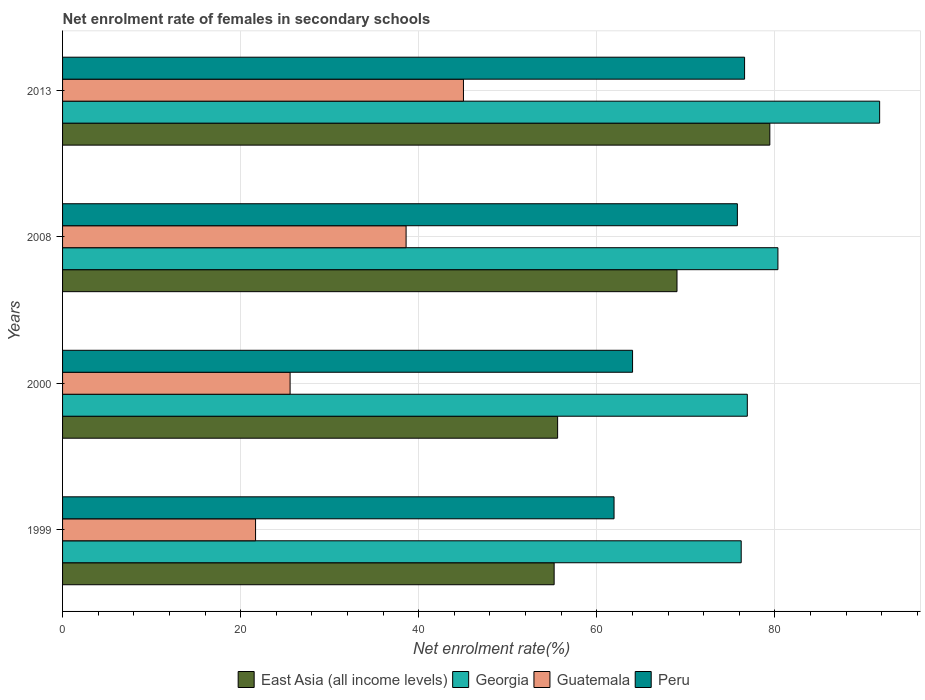How many different coloured bars are there?
Provide a short and direct response. 4. How many groups of bars are there?
Give a very brief answer. 4. Are the number of bars per tick equal to the number of legend labels?
Your answer should be compact. Yes. How many bars are there on the 1st tick from the bottom?
Your answer should be compact. 4. In how many cases, is the number of bars for a given year not equal to the number of legend labels?
Provide a short and direct response. 0. What is the net enrolment rate of females in secondary schools in East Asia (all income levels) in 1999?
Offer a very short reply. 55.21. Across all years, what is the maximum net enrolment rate of females in secondary schools in East Asia (all income levels)?
Ensure brevity in your answer.  79.43. Across all years, what is the minimum net enrolment rate of females in secondary schools in Peru?
Your answer should be compact. 61.94. In which year was the net enrolment rate of females in secondary schools in Georgia minimum?
Offer a very short reply. 1999. What is the total net enrolment rate of females in secondary schools in Guatemala in the graph?
Your answer should be very brief. 130.83. What is the difference between the net enrolment rate of females in secondary schools in Georgia in 1999 and that in 2008?
Provide a short and direct response. -4.12. What is the difference between the net enrolment rate of females in secondary schools in Guatemala in 2000 and the net enrolment rate of females in secondary schools in East Asia (all income levels) in 1999?
Ensure brevity in your answer.  -29.66. What is the average net enrolment rate of females in secondary schools in East Asia (all income levels) per year?
Make the answer very short. 64.81. In the year 2008, what is the difference between the net enrolment rate of females in secondary schools in Georgia and net enrolment rate of females in secondary schools in Peru?
Offer a terse response. 4.55. In how many years, is the net enrolment rate of females in secondary schools in Georgia greater than 52 %?
Keep it short and to the point. 4. What is the ratio of the net enrolment rate of females in secondary schools in Georgia in 1999 to that in 2008?
Give a very brief answer. 0.95. What is the difference between the highest and the second highest net enrolment rate of females in secondary schools in East Asia (all income levels)?
Your response must be concise. 10.43. What is the difference between the highest and the lowest net enrolment rate of females in secondary schools in Georgia?
Make the answer very short. 15.55. What does the 3rd bar from the top in 2000 represents?
Give a very brief answer. Georgia. What does the 1st bar from the bottom in 2013 represents?
Offer a very short reply. East Asia (all income levels). How many bars are there?
Ensure brevity in your answer.  16. How many years are there in the graph?
Provide a succinct answer. 4. What is the difference between two consecutive major ticks on the X-axis?
Keep it short and to the point. 20. Does the graph contain grids?
Offer a terse response. Yes. Where does the legend appear in the graph?
Your response must be concise. Bottom center. How are the legend labels stacked?
Give a very brief answer. Horizontal. What is the title of the graph?
Your response must be concise. Net enrolment rate of females in secondary schools. Does "Upper middle income" appear as one of the legend labels in the graph?
Ensure brevity in your answer.  No. What is the label or title of the X-axis?
Your response must be concise. Net enrolment rate(%). What is the label or title of the Y-axis?
Offer a very short reply. Years. What is the Net enrolment rate(%) of East Asia (all income levels) in 1999?
Offer a very short reply. 55.21. What is the Net enrolment rate(%) of Georgia in 1999?
Keep it short and to the point. 76.22. What is the Net enrolment rate(%) of Guatemala in 1999?
Give a very brief answer. 21.68. What is the Net enrolment rate(%) of Peru in 1999?
Your answer should be compact. 61.94. What is the Net enrolment rate(%) in East Asia (all income levels) in 2000?
Offer a terse response. 55.6. What is the Net enrolment rate(%) in Georgia in 2000?
Offer a very short reply. 76.9. What is the Net enrolment rate(%) of Guatemala in 2000?
Offer a very short reply. 25.55. What is the Net enrolment rate(%) of Peru in 2000?
Ensure brevity in your answer.  64.02. What is the Net enrolment rate(%) of East Asia (all income levels) in 2008?
Offer a very short reply. 69.01. What is the Net enrolment rate(%) in Georgia in 2008?
Ensure brevity in your answer.  80.34. What is the Net enrolment rate(%) in Guatemala in 2008?
Make the answer very short. 38.58. What is the Net enrolment rate(%) in Peru in 2008?
Provide a succinct answer. 75.79. What is the Net enrolment rate(%) in East Asia (all income levels) in 2013?
Offer a very short reply. 79.43. What is the Net enrolment rate(%) of Georgia in 2013?
Your answer should be compact. 91.77. What is the Net enrolment rate(%) in Guatemala in 2013?
Give a very brief answer. 45.02. What is the Net enrolment rate(%) of Peru in 2013?
Keep it short and to the point. 76.6. Across all years, what is the maximum Net enrolment rate(%) of East Asia (all income levels)?
Provide a short and direct response. 79.43. Across all years, what is the maximum Net enrolment rate(%) in Georgia?
Keep it short and to the point. 91.77. Across all years, what is the maximum Net enrolment rate(%) of Guatemala?
Your answer should be very brief. 45.02. Across all years, what is the maximum Net enrolment rate(%) in Peru?
Offer a very short reply. 76.6. Across all years, what is the minimum Net enrolment rate(%) of East Asia (all income levels)?
Your response must be concise. 55.21. Across all years, what is the minimum Net enrolment rate(%) in Georgia?
Offer a very short reply. 76.22. Across all years, what is the minimum Net enrolment rate(%) in Guatemala?
Provide a succinct answer. 21.68. Across all years, what is the minimum Net enrolment rate(%) of Peru?
Offer a very short reply. 61.94. What is the total Net enrolment rate(%) of East Asia (all income levels) in the graph?
Provide a short and direct response. 259.25. What is the total Net enrolment rate(%) of Georgia in the graph?
Your answer should be very brief. 325.23. What is the total Net enrolment rate(%) of Guatemala in the graph?
Ensure brevity in your answer.  130.83. What is the total Net enrolment rate(%) of Peru in the graph?
Provide a succinct answer. 278.34. What is the difference between the Net enrolment rate(%) of East Asia (all income levels) in 1999 and that in 2000?
Offer a terse response. -0.39. What is the difference between the Net enrolment rate(%) of Georgia in 1999 and that in 2000?
Offer a terse response. -0.69. What is the difference between the Net enrolment rate(%) in Guatemala in 1999 and that in 2000?
Provide a short and direct response. -3.88. What is the difference between the Net enrolment rate(%) in Peru in 1999 and that in 2000?
Your answer should be compact. -2.08. What is the difference between the Net enrolment rate(%) of East Asia (all income levels) in 1999 and that in 2008?
Your answer should be compact. -13.8. What is the difference between the Net enrolment rate(%) of Georgia in 1999 and that in 2008?
Make the answer very short. -4.12. What is the difference between the Net enrolment rate(%) of Guatemala in 1999 and that in 2008?
Offer a terse response. -16.91. What is the difference between the Net enrolment rate(%) in Peru in 1999 and that in 2008?
Make the answer very short. -13.85. What is the difference between the Net enrolment rate(%) in East Asia (all income levels) in 1999 and that in 2013?
Your response must be concise. -24.22. What is the difference between the Net enrolment rate(%) in Georgia in 1999 and that in 2013?
Ensure brevity in your answer.  -15.55. What is the difference between the Net enrolment rate(%) in Guatemala in 1999 and that in 2013?
Keep it short and to the point. -23.35. What is the difference between the Net enrolment rate(%) in Peru in 1999 and that in 2013?
Make the answer very short. -14.66. What is the difference between the Net enrolment rate(%) of East Asia (all income levels) in 2000 and that in 2008?
Your answer should be compact. -13.41. What is the difference between the Net enrolment rate(%) of Georgia in 2000 and that in 2008?
Make the answer very short. -3.44. What is the difference between the Net enrolment rate(%) of Guatemala in 2000 and that in 2008?
Give a very brief answer. -13.03. What is the difference between the Net enrolment rate(%) of Peru in 2000 and that in 2008?
Provide a succinct answer. -11.77. What is the difference between the Net enrolment rate(%) of East Asia (all income levels) in 2000 and that in 2013?
Provide a succinct answer. -23.83. What is the difference between the Net enrolment rate(%) in Georgia in 2000 and that in 2013?
Provide a short and direct response. -14.86. What is the difference between the Net enrolment rate(%) of Guatemala in 2000 and that in 2013?
Offer a very short reply. -19.47. What is the difference between the Net enrolment rate(%) in Peru in 2000 and that in 2013?
Ensure brevity in your answer.  -12.58. What is the difference between the Net enrolment rate(%) of East Asia (all income levels) in 2008 and that in 2013?
Offer a very short reply. -10.43. What is the difference between the Net enrolment rate(%) of Georgia in 2008 and that in 2013?
Give a very brief answer. -11.42. What is the difference between the Net enrolment rate(%) in Guatemala in 2008 and that in 2013?
Provide a short and direct response. -6.44. What is the difference between the Net enrolment rate(%) of Peru in 2008 and that in 2013?
Offer a very short reply. -0.81. What is the difference between the Net enrolment rate(%) of East Asia (all income levels) in 1999 and the Net enrolment rate(%) of Georgia in 2000?
Provide a succinct answer. -21.69. What is the difference between the Net enrolment rate(%) of East Asia (all income levels) in 1999 and the Net enrolment rate(%) of Guatemala in 2000?
Offer a terse response. 29.66. What is the difference between the Net enrolment rate(%) of East Asia (all income levels) in 1999 and the Net enrolment rate(%) of Peru in 2000?
Your answer should be very brief. -8.81. What is the difference between the Net enrolment rate(%) in Georgia in 1999 and the Net enrolment rate(%) in Guatemala in 2000?
Give a very brief answer. 50.66. What is the difference between the Net enrolment rate(%) of Georgia in 1999 and the Net enrolment rate(%) of Peru in 2000?
Make the answer very short. 12.2. What is the difference between the Net enrolment rate(%) of Guatemala in 1999 and the Net enrolment rate(%) of Peru in 2000?
Ensure brevity in your answer.  -42.34. What is the difference between the Net enrolment rate(%) of East Asia (all income levels) in 1999 and the Net enrolment rate(%) of Georgia in 2008?
Provide a succinct answer. -25.13. What is the difference between the Net enrolment rate(%) of East Asia (all income levels) in 1999 and the Net enrolment rate(%) of Guatemala in 2008?
Your answer should be very brief. 16.63. What is the difference between the Net enrolment rate(%) of East Asia (all income levels) in 1999 and the Net enrolment rate(%) of Peru in 2008?
Offer a terse response. -20.58. What is the difference between the Net enrolment rate(%) of Georgia in 1999 and the Net enrolment rate(%) of Guatemala in 2008?
Offer a very short reply. 37.64. What is the difference between the Net enrolment rate(%) of Georgia in 1999 and the Net enrolment rate(%) of Peru in 2008?
Give a very brief answer. 0.43. What is the difference between the Net enrolment rate(%) in Guatemala in 1999 and the Net enrolment rate(%) in Peru in 2008?
Ensure brevity in your answer.  -54.11. What is the difference between the Net enrolment rate(%) of East Asia (all income levels) in 1999 and the Net enrolment rate(%) of Georgia in 2013?
Your answer should be very brief. -36.56. What is the difference between the Net enrolment rate(%) in East Asia (all income levels) in 1999 and the Net enrolment rate(%) in Guatemala in 2013?
Your answer should be compact. 10.19. What is the difference between the Net enrolment rate(%) in East Asia (all income levels) in 1999 and the Net enrolment rate(%) in Peru in 2013?
Provide a succinct answer. -21.39. What is the difference between the Net enrolment rate(%) in Georgia in 1999 and the Net enrolment rate(%) in Guatemala in 2013?
Make the answer very short. 31.2. What is the difference between the Net enrolment rate(%) of Georgia in 1999 and the Net enrolment rate(%) of Peru in 2013?
Provide a succinct answer. -0.38. What is the difference between the Net enrolment rate(%) in Guatemala in 1999 and the Net enrolment rate(%) in Peru in 2013?
Make the answer very short. -54.92. What is the difference between the Net enrolment rate(%) in East Asia (all income levels) in 2000 and the Net enrolment rate(%) in Georgia in 2008?
Ensure brevity in your answer.  -24.74. What is the difference between the Net enrolment rate(%) of East Asia (all income levels) in 2000 and the Net enrolment rate(%) of Guatemala in 2008?
Make the answer very short. 17.02. What is the difference between the Net enrolment rate(%) of East Asia (all income levels) in 2000 and the Net enrolment rate(%) of Peru in 2008?
Provide a succinct answer. -20.19. What is the difference between the Net enrolment rate(%) of Georgia in 2000 and the Net enrolment rate(%) of Guatemala in 2008?
Ensure brevity in your answer.  38.32. What is the difference between the Net enrolment rate(%) of Georgia in 2000 and the Net enrolment rate(%) of Peru in 2008?
Your answer should be compact. 1.12. What is the difference between the Net enrolment rate(%) in Guatemala in 2000 and the Net enrolment rate(%) in Peru in 2008?
Provide a succinct answer. -50.23. What is the difference between the Net enrolment rate(%) in East Asia (all income levels) in 2000 and the Net enrolment rate(%) in Georgia in 2013?
Keep it short and to the point. -36.17. What is the difference between the Net enrolment rate(%) of East Asia (all income levels) in 2000 and the Net enrolment rate(%) of Guatemala in 2013?
Make the answer very short. 10.58. What is the difference between the Net enrolment rate(%) in East Asia (all income levels) in 2000 and the Net enrolment rate(%) in Peru in 2013?
Offer a terse response. -21. What is the difference between the Net enrolment rate(%) in Georgia in 2000 and the Net enrolment rate(%) in Guatemala in 2013?
Your answer should be very brief. 31.88. What is the difference between the Net enrolment rate(%) of Georgia in 2000 and the Net enrolment rate(%) of Peru in 2013?
Provide a succinct answer. 0.31. What is the difference between the Net enrolment rate(%) of Guatemala in 2000 and the Net enrolment rate(%) of Peru in 2013?
Your response must be concise. -51.04. What is the difference between the Net enrolment rate(%) of East Asia (all income levels) in 2008 and the Net enrolment rate(%) of Georgia in 2013?
Provide a succinct answer. -22.76. What is the difference between the Net enrolment rate(%) in East Asia (all income levels) in 2008 and the Net enrolment rate(%) in Guatemala in 2013?
Provide a succinct answer. 23.98. What is the difference between the Net enrolment rate(%) in East Asia (all income levels) in 2008 and the Net enrolment rate(%) in Peru in 2013?
Offer a terse response. -7.59. What is the difference between the Net enrolment rate(%) of Georgia in 2008 and the Net enrolment rate(%) of Guatemala in 2013?
Provide a succinct answer. 35.32. What is the difference between the Net enrolment rate(%) of Georgia in 2008 and the Net enrolment rate(%) of Peru in 2013?
Offer a terse response. 3.75. What is the difference between the Net enrolment rate(%) of Guatemala in 2008 and the Net enrolment rate(%) of Peru in 2013?
Offer a terse response. -38.02. What is the average Net enrolment rate(%) of East Asia (all income levels) per year?
Offer a very short reply. 64.81. What is the average Net enrolment rate(%) of Georgia per year?
Give a very brief answer. 81.31. What is the average Net enrolment rate(%) of Guatemala per year?
Offer a very short reply. 32.71. What is the average Net enrolment rate(%) in Peru per year?
Provide a short and direct response. 69.58. In the year 1999, what is the difference between the Net enrolment rate(%) of East Asia (all income levels) and Net enrolment rate(%) of Georgia?
Keep it short and to the point. -21.01. In the year 1999, what is the difference between the Net enrolment rate(%) in East Asia (all income levels) and Net enrolment rate(%) in Guatemala?
Your answer should be very brief. 33.53. In the year 1999, what is the difference between the Net enrolment rate(%) of East Asia (all income levels) and Net enrolment rate(%) of Peru?
Your answer should be compact. -6.73. In the year 1999, what is the difference between the Net enrolment rate(%) of Georgia and Net enrolment rate(%) of Guatemala?
Keep it short and to the point. 54.54. In the year 1999, what is the difference between the Net enrolment rate(%) in Georgia and Net enrolment rate(%) in Peru?
Offer a terse response. 14.28. In the year 1999, what is the difference between the Net enrolment rate(%) in Guatemala and Net enrolment rate(%) in Peru?
Your answer should be compact. -40.26. In the year 2000, what is the difference between the Net enrolment rate(%) of East Asia (all income levels) and Net enrolment rate(%) of Georgia?
Keep it short and to the point. -21.3. In the year 2000, what is the difference between the Net enrolment rate(%) in East Asia (all income levels) and Net enrolment rate(%) in Guatemala?
Give a very brief answer. 30.05. In the year 2000, what is the difference between the Net enrolment rate(%) in East Asia (all income levels) and Net enrolment rate(%) in Peru?
Your answer should be compact. -8.42. In the year 2000, what is the difference between the Net enrolment rate(%) in Georgia and Net enrolment rate(%) in Guatemala?
Your answer should be very brief. 51.35. In the year 2000, what is the difference between the Net enrolment rate(%) in Georgia and Net enrolment rate(%) in Peru?
Provide a short and direct response. 12.89. In the year 2000, what is the difference between the Net enrolment rate(%) of Guatemala and Net enrolment rate(%) of Peru?
Offer a very short reply. -38.46. In the year 2008, what is the difference between the Net enrolment rate(%) in East Asia (all income levels) and Net enrolment rate(%) in Georgia?
Offer a terse response. -11.33. In the year 2008, what is the difference between the Net enrolment rate(%) in East Asia (all income levels) and Net enrolment rate(%) in Guatemala?
Keep it short and to the point. 30.43. In the year 2008, what is the difference between the Net enrolment rate(%) in East Asia (all income levels) and Net enrolment rate(%) in Peru?
Offer a terse response. -6.78. In the year 2008, what is the difference between the Net enrolment rate(%) in Georgia and Net enrolment rate(%) in Guatemala?
Ensure brevity in your answer.  41.76. In the year 2008, what is the difference between the Net enrolment rate(%) in Georgia and Net enrolment rate(%) in Peru?
Your response must be concise. 4.55. In the year 2008, what is the difference between the Net enrolment rate(%) of Guatemala and Net enrolment rate(%) of Peru?
Give a very brief answer. -37.21. In the year 2013, what is the difference between the Net enrolment rate(%) in East Asia (all income levels) and Net enrolment rate(%) in Georgia?
Ensure brevity in your answer.  -12.33. In the year 2013, what is the difference between the Net enrolment rate(%) of East Asia (all income levels) and Net enrolment rate(%) of Guatemala?
Keep it short and to the point. 34.41. In the year 2013, what is the difference between the Net enrolment rate(%) of East Asia (all income levels) and Net enrolment rate(%) of Peru?
Your answer should be compact. 2.84. In the year 2013, what is the difference between the Net enrolment rate(%) in Georgia and Net enrolment rate(%) in Guatemala?
Offer a terse response. 46.74. In the year 2013, what is the difference between the Net enrolment rate(%) of Georgia and Net enrolment rate(%) of Peru?
Give a very brief answer. 15.17. In the year 2013, what is the difference between the Net enrolment rate(%) of Guatemala and Net enrolment rate(%) of Peru?
Your answer should be compact. -31.57. What is the ratio of the Net enrolment rate(%) of Guatemala in 1999 to that in 2000?
Give a very brief answer. 0.85. What is the ratio of the Net enrolment rate(%) in Peru in 1999 to that in 2000?
Your answer should be very brief. 0.97. What is the ratio of the Net enrolment rate(%) in East Asia (all income levels) in 1999 to that in 2008?
Provide a short and direct response. 0.8. What is the ratio of the Net enrolment rate(%) in Georgia in 1999 to that in 2008?
Provide a succinct answer. 0.95. What is the ratio of the Net enrolment rate(%) in Guatemala in 1999 to that in 2008?
Ensure brevity in your answer.  0.56. What is the ratio of the Net enrolment rate(%) in Peru in 1999 to that in 2008?
Your answer should be very brief. 0.82. What is the ratio of the Net enrolment rate(%) of East Asia (all income levels) in 1999 to that in 2013?
Your answer should be very brief. 0.69. What is the ratio of the Net enrolment rate(%) in Georgia in 1999 to that in 2013?
Give a very brief answer. 0.83. What is the ratio of the Net enrolment rate(%) in Guatemala in 1999 to that in 2013?
Give a very brief answer. 0.48. What is the ratio of the Net enrolment rate(%) of Peru in 1999 to that in 2013?
Provide a succinct answer. 0.81. What is the ratio of the Net enrolment rate(%) of East Asia (all income levels) in 2000 to that in 2008?
Offer a very short reply. 0.81. What is the ratio of the Net enrolment rate(%) in Georgia in 2000 to that in 2008?
Provide a succinct answer. 0.96. What is the ratio of the Net enrolment rate(%) of Guatemala in 2000 to that in 2008?
Provide a short and direct response. 0.66. What is the ratio of the Net enrolment rate(%) of Peru in 2000 to that in 2008?
Your response must be concise. 0.84. What is the ratio of the Net enrolment rate(%) of Georgia in 2000 to that in 2013?
Ensure brevity in your answer.  0.84. What is the ratio of the Net enrolment rate(%) in Guatemala in 2000 to that in 2013?
Your answer should be compact. 0.57. What is the ratio of the Net enrolment rate(%) of Peru in 2000 to that in 2013?
Your answer should be compact. 0.84. What is the ratio of the Net enrolment rate(%) in East Asia (all income levels) in 2008 to that in 2013?
Give a very brief answer. 0.87. What is the ratio of the Net enrolment rate(%) in Georgia in 2008 to that in 2013?
Make the answer very short. 0.88. What is the ratio of the Net enrolment rate(%) of Guatemala in 2008 to that in 2013?
Provide a succinct answer. 0.86. What is the difference between the highest and the second highest Net enrolment rate(%) in East Asia (all income levels)?
Make the answer very short. 10.43. What is the difference between the highest and the second highest Net enrolment rate(%) in Georgia?
Ensure brevity in your answer.  11.42. What is the difference between the highest and the second highest Net enrolment rate(%) of Guatemala?
Your answer should be compact. 6.44. What is the difference between the highest and the second highest Net enrolment rate(%) of Peru?
Provide a short and direct response. 0.81. What is the difference between the highest and the lowest Net enrolment rate(%) of East Asia (all income levels)?
Provide a short and direct response. 24.22. What is the difference between the highest and the lowest Net enrolment rate(%) in Georgia?
Offer a very short reply. 15.55. What is the difference between the highest and the lowest Net enrolment rate(%) in Guatemala?
Offer a terse response. 23.35. What is the difference between the highest and the lowest Net enrolment rate(%) of Peru?
Keep it short and to the point. 14.66. 